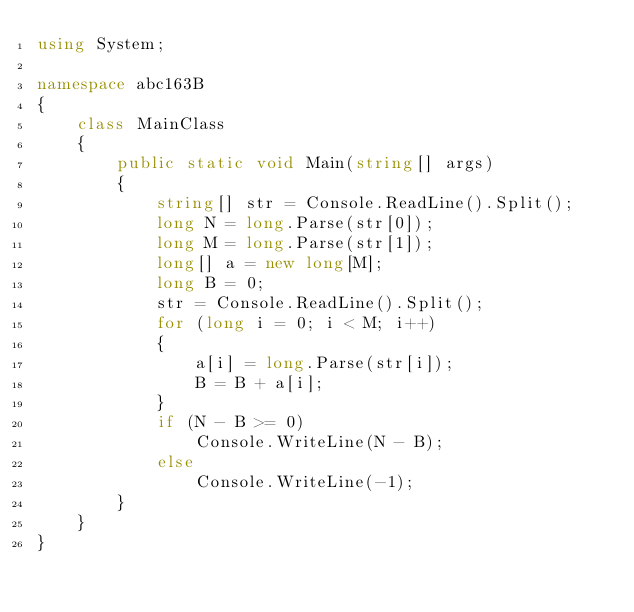Convert code to text. <code><loc_0><loc_0><loc_500><loc_500><_C#_>using System;

namespace abc163B
{
    class MainClass
    {
        public static void Main(string[] args)
        {
            string[] str = Console.ReadLine().Split();
            long N = long.Parse(str[0]);
            long M = long.Parse(str[1]);
            long[] a = new long[M];
            long B = 0;
            str = Console.ReadLine().Split();
            for (long i = 0; i < M; i++)
            {
                a[i] = long.Parse(str[i]);
                B = B + a[i];
            }
            if (N - B >= 0)
                Console.WriteLine(N - B);
            else
                Console.WriteLine(-1);
        }
    }
}
</code> 